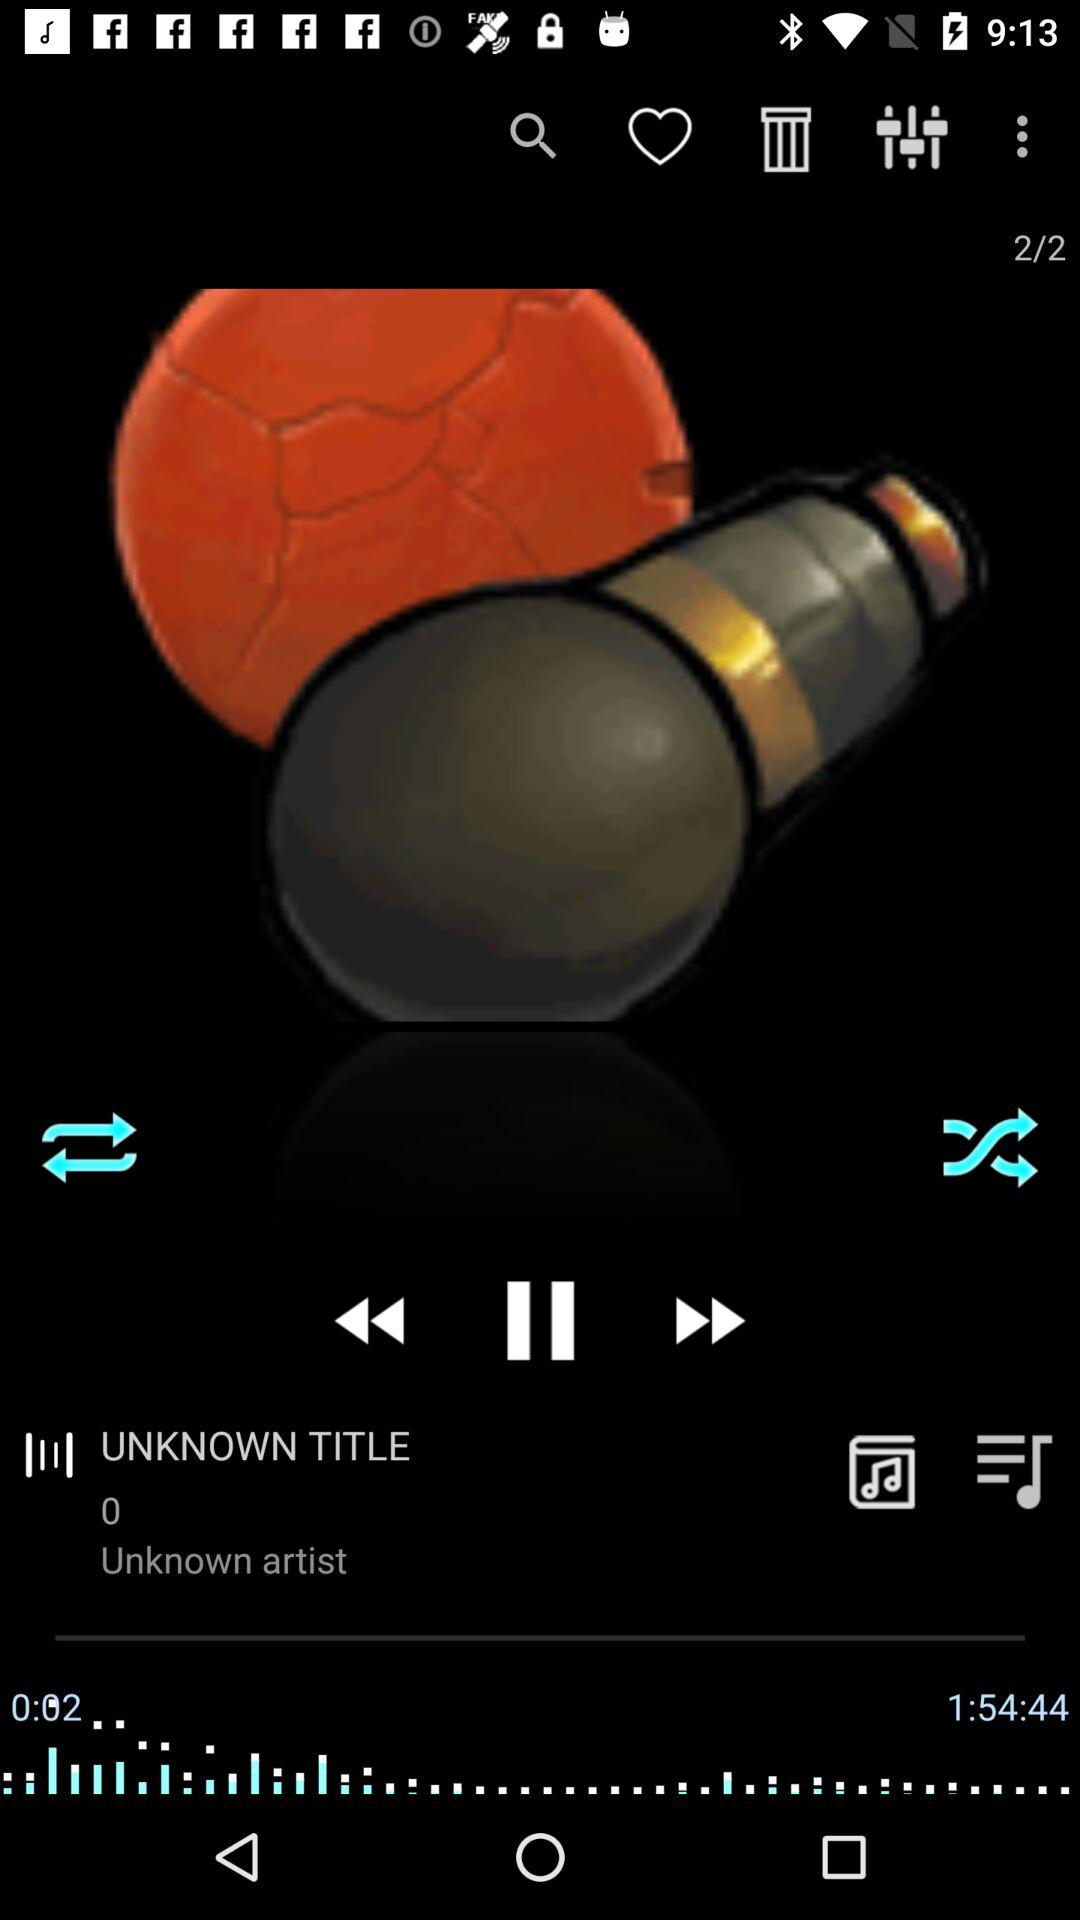What is the name of the song? The name of the song is "UNKNOWN TITLE". 